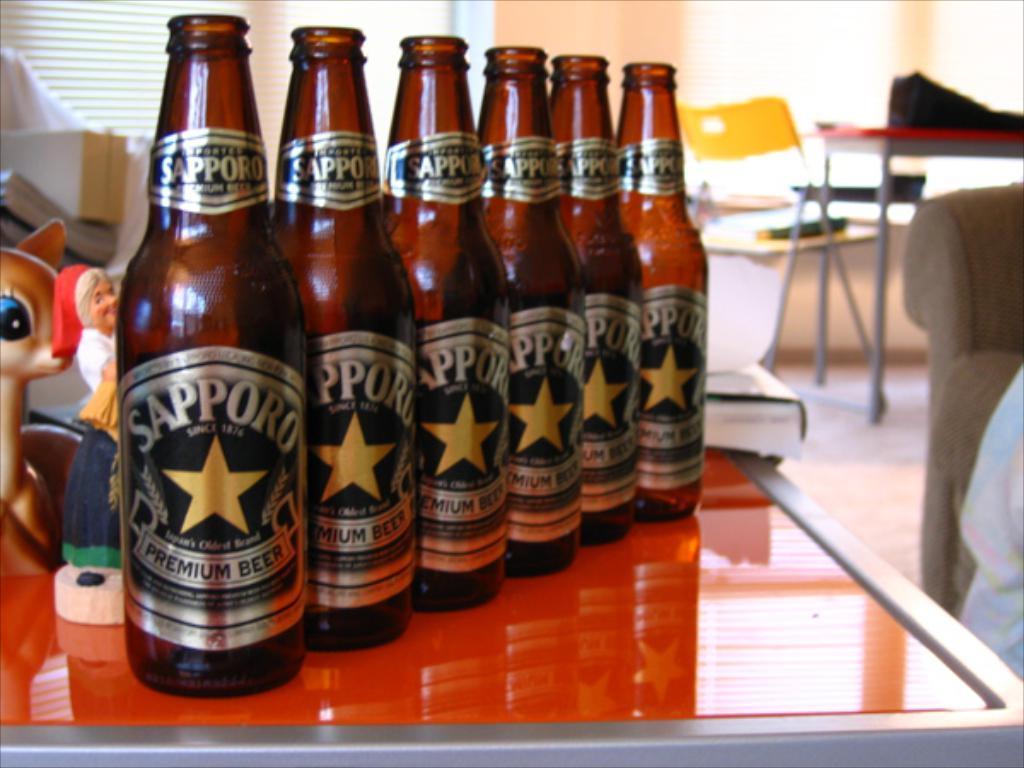Can you describe this image briefly? This picture is of inside the room. In the foreground there is a red color table on the top of which glass bottles are placed and some toys and also placed. In the background we can see the table, yellow color chair, window blind and the wall. 